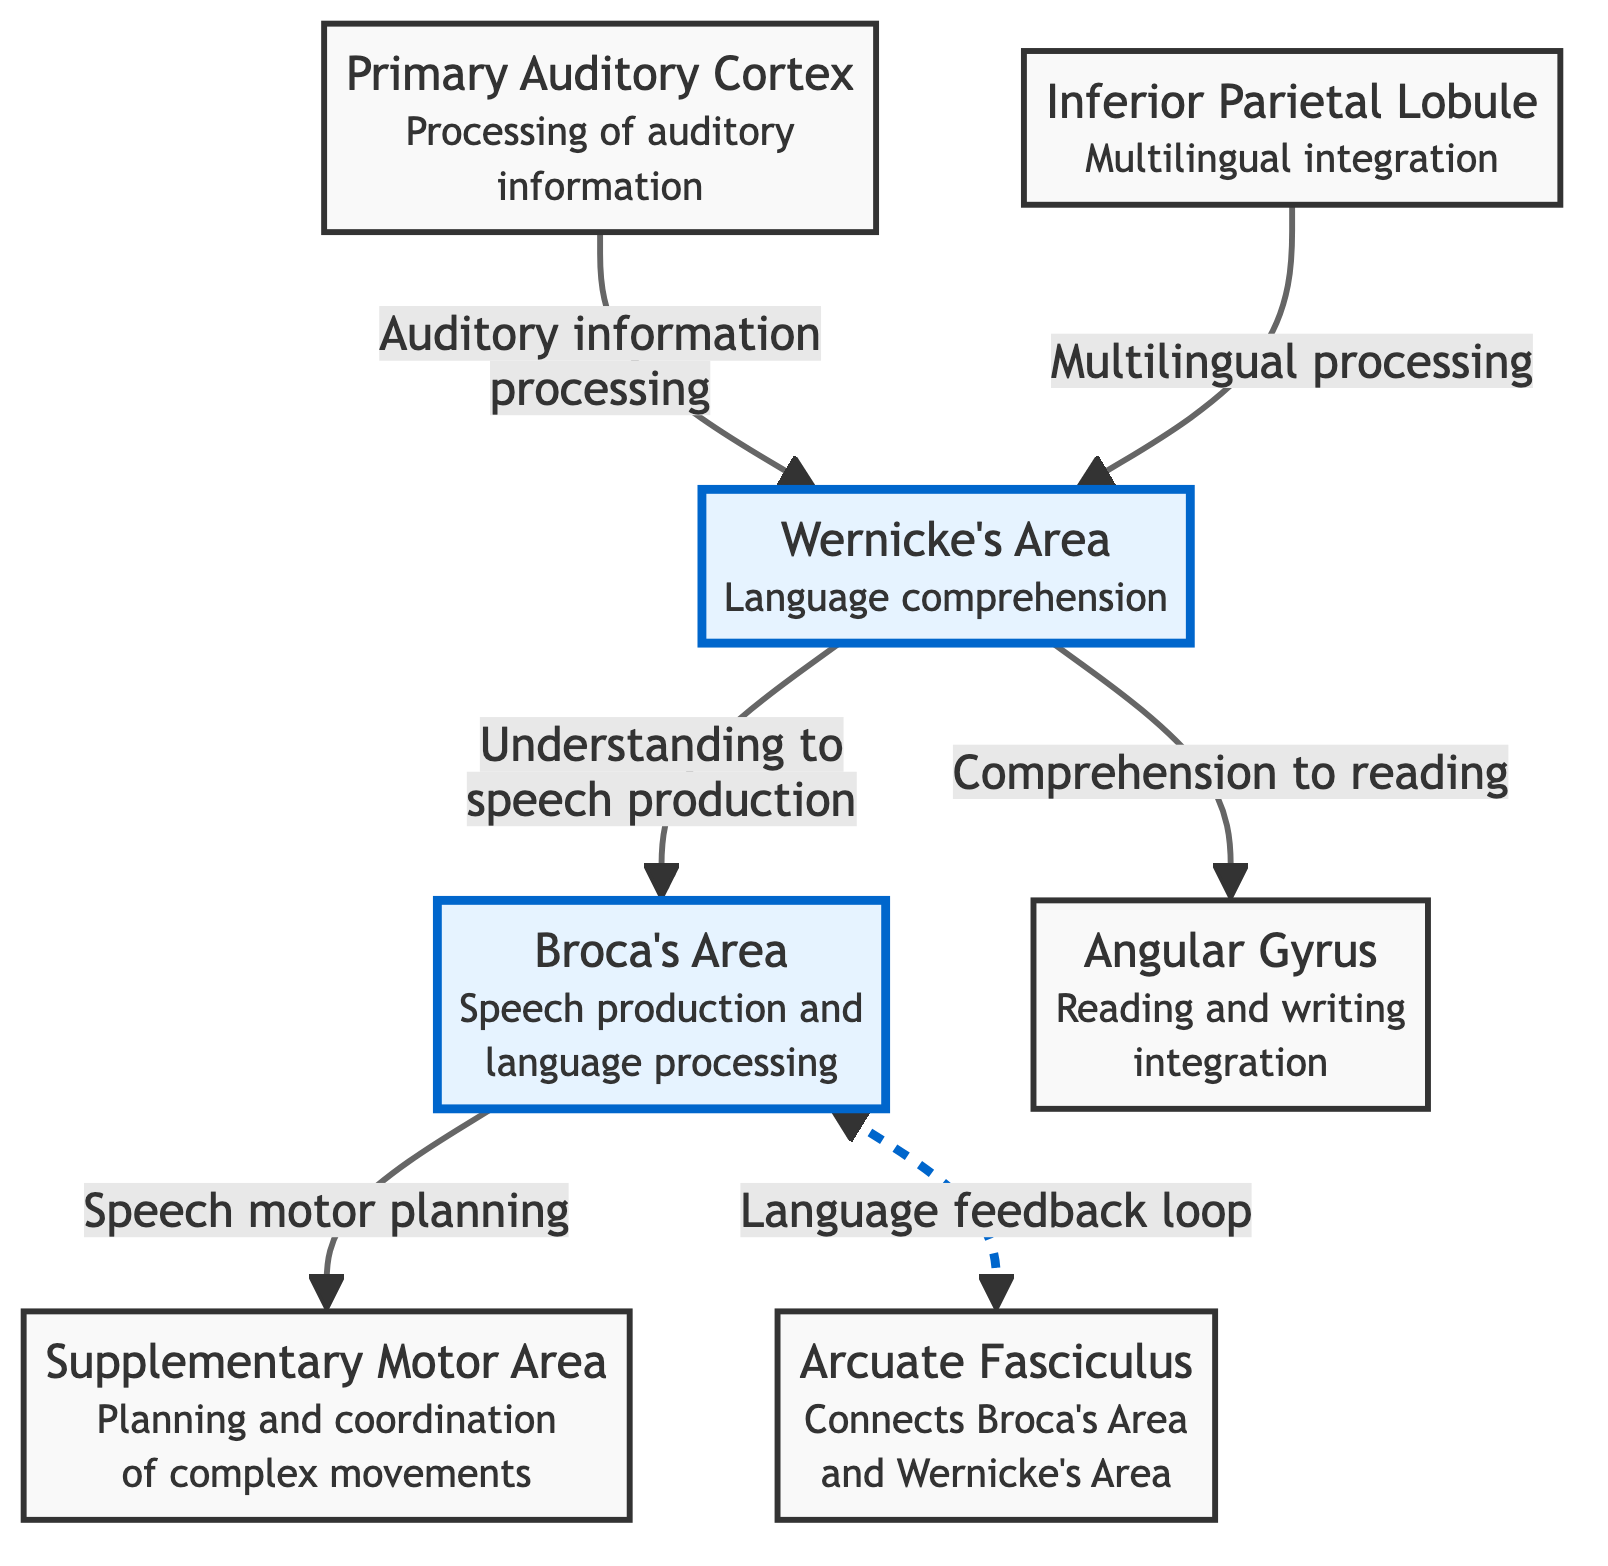What is the primary function of Broca's Area? Broca's Area is specifically labeled with "Speech production and language processing" in the diagram, indicating its primary role in generating speech and processing language.
Answer: Speech production and language processing How many regions are highlighted in the diagram? The diagram shows two highlighted regions, which are Broca's Area and Wernicke's Area, designed to emphasize their importance.
Answer: 2 Which area is responsible for language comprehension? Wernicke's Area is explicitly identified in the diagram with the description "Language comprehension," making it clear that this region serves that function.
Answer: Wernicke's Area What connects Broca's Area and Wernicke's Area? The name "Arcuate Fasciculus" is displayed in the diagram, indicating the bundle of nerves that connect both areas, facilitating communication between them.
Answer: Arcuate Fasciculus What region integrates reading and writing? The diagram shows "Angular Gyrus" with the description "Reading and writing integration," clearly identifying it as the region responsible for these functions.
Answer: Angular Gyrus What type of processing is indicated for the Inferior Parietal Lobule? The "Inferior Parietal Lobule" is marked with "Multilingual integration," indicating its role in processing multiple languages within the brain.
Answer: Multilingual integration What is the relationship between Wernicke's Area and the Angular Gyrus? Wernicke's Area is connected to the Angular Gyrus by an arrow labeled "Comprehension to reading," indicating that comprehension processes contribute to reading abilities.
Answer: Comprehension to reading Which area is involved in speech motor planning? The diagram designates "Supplementary Motor Area" with the description "Planning and coordination of complex movements," indicating its involvement in motor planning related to speech.
Answer: Supplementary Motor Area How does auditory information relate to Wernicke's Area? The flow from "Primary Auditory Cortex" to "Wernicke's Area" is labeled "Auditory information processing," illustrating that auditory input is processed before comprehension in Wernicke's Area.
Answer: Auditory information processing 